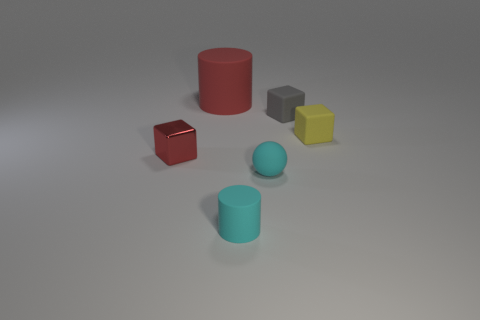Add 2 tiny gray rubber cubes. How many objects exist? 8 Subtract all matte cubes. How many cubes are left? 1 Subtract all tiny gray rubber things. Subtract all big cylinders. How many objects are left? 4 Add 2 big rubber cylinders. How many big rubber cylinders are left? 3 Add 6 tiny red metal things. How many tiny red metal things exist? 7 Subtract all cyan cylinders. How many cylinders are left? 1 Subtract 1 gray blocks. How many objects are left? 5 Subtract all cylinders. How many objects are left? 4 Subtract 1 cylinders. How many cylinders are left? 1 Subtract all red cylinders. Subtract all brown balls. How many cylinders are left? 1 